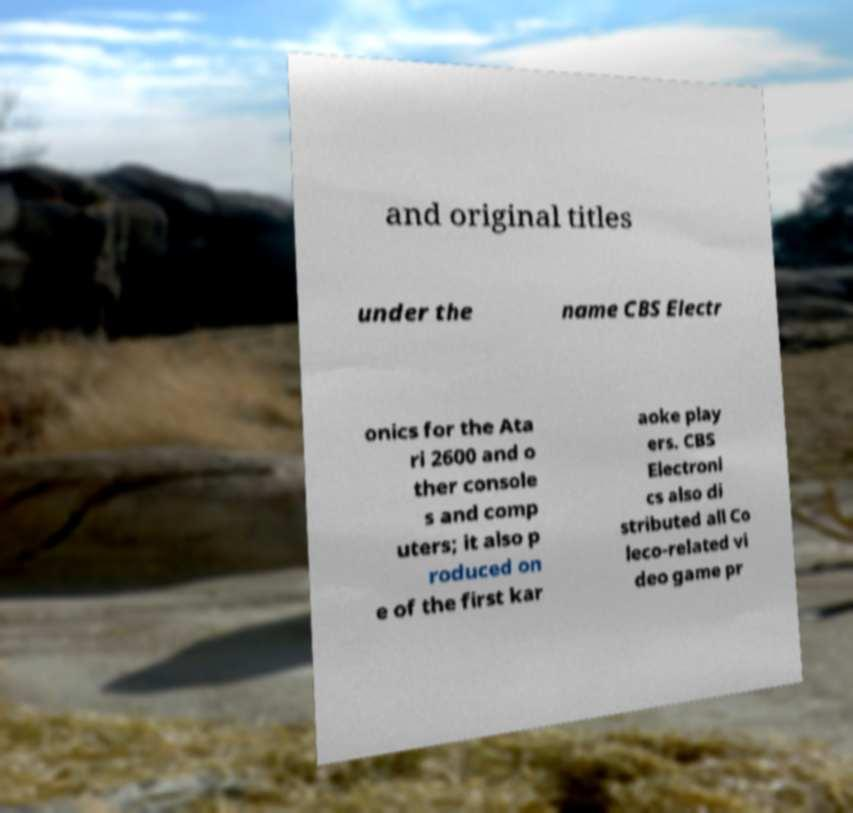Could you assist in decoding the text presented in this image and type it out clearly? and original titles under the name CBS Electr onics for the Ata ri 2600 and o ther console s and comp uters; it also p roduced on e of the first kar aoke play ers. CBS Electroni cs also di stributed all Co leco-related vi deo game pr 